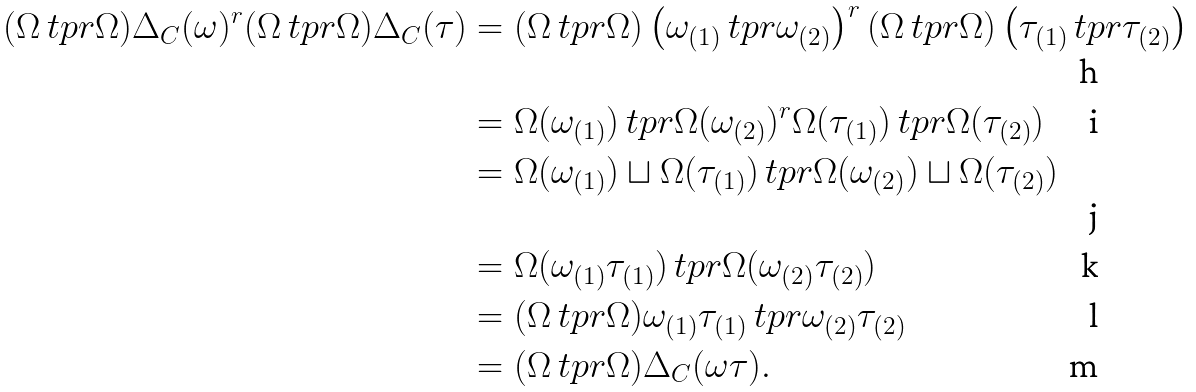Convert formula to latex. <formula><loc_0><loc_0><loc_500><loc_500>( \Omega \ t p r \Omega ) \Delta _ { C } ( \omega ) ^ { r } ( \Omega \ t p r \Omega ) \Delta _ { C } ( \tau ) & = ( \Omega \ t p r \Omega ) \left ( \omega _ { ( 1 ) } \ t p r \omega _ { ( 2 ) } \right ) ^ { r } ( \Omega \ t p r \Omega ) \left ( \tau _ { ( 1 ) } \ t p r \tau _ { ( 2 ) } \right ) \\ & = \Omega ( \omega _ { ( 1 ) } ) \ t p r \Omega ( \omega _ { ( 2 ) } ) ^ { r } \Omega ( \tau _ { ( 1 ) } ) \ t p r \Omega ( \tau _ { ( 2 ) } ) \\ & = \Omega ( \omega _ { ( 1 ) } ) \sqcup \Omega ( \tau _ { ( 1 ) } ) \ t p r \Omega ( \omega _ { ( 2 ) } ) \sqcup \Omega ( \tau _ { ( 2 ) } ) \\ & = \Omega ( \omega _ { ( 1 ) } \tau _ { ( 1 ) } ) \ t p r \Omega ( \omega _ { ( 2 ) } \tau _ { ( 2 ) } ) \\ & = ( \Omega \ t p r \Omega ) \omega _ { ( 1 ) } \tau _ { ( 1 ) } \ t p r \omega _ { ( 2 ) } \tau _ { ( 2 ) } \\ & = ( \Omega \ t p r \Omega ) \Delta _ { C } ( \omega \tau ) .</formula> 